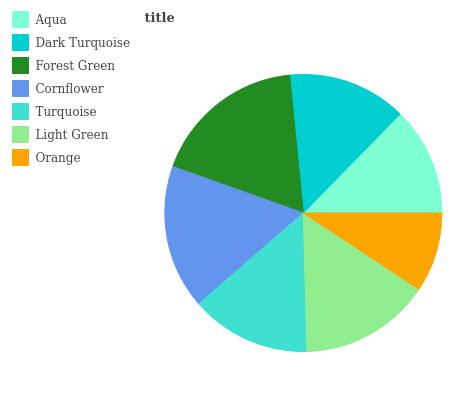Is Orange the minimum?
Answer yes or no. Yes. Is Forest Green the maximum?
Answer yes or no. Yes. Is Dark Turquoise the minimum?
Answer yes or no. No. Is Dark Turquoise the maximum?
Answer yes or no. No. Is Dark Turquoise greater than Aqua?
Answer yes or no. Yes. Is Aqua less than Dark Turquoise?
Answer yes or no. Yes. Is Aqua greater than Dark Turquoise?
Answer yes or no. No. Is Dark Turquoise less than Aqua?
Answer yes or no. No. Is Turquoise the high median?
Answer yes or no. Yes. Is Turquoise the low median?
Answer yes or no. Yes. Is Dark Turquoise the high median?
Answer yes or no. No. Is Dark Turquoise the low median?
Answer yes or no. No. 